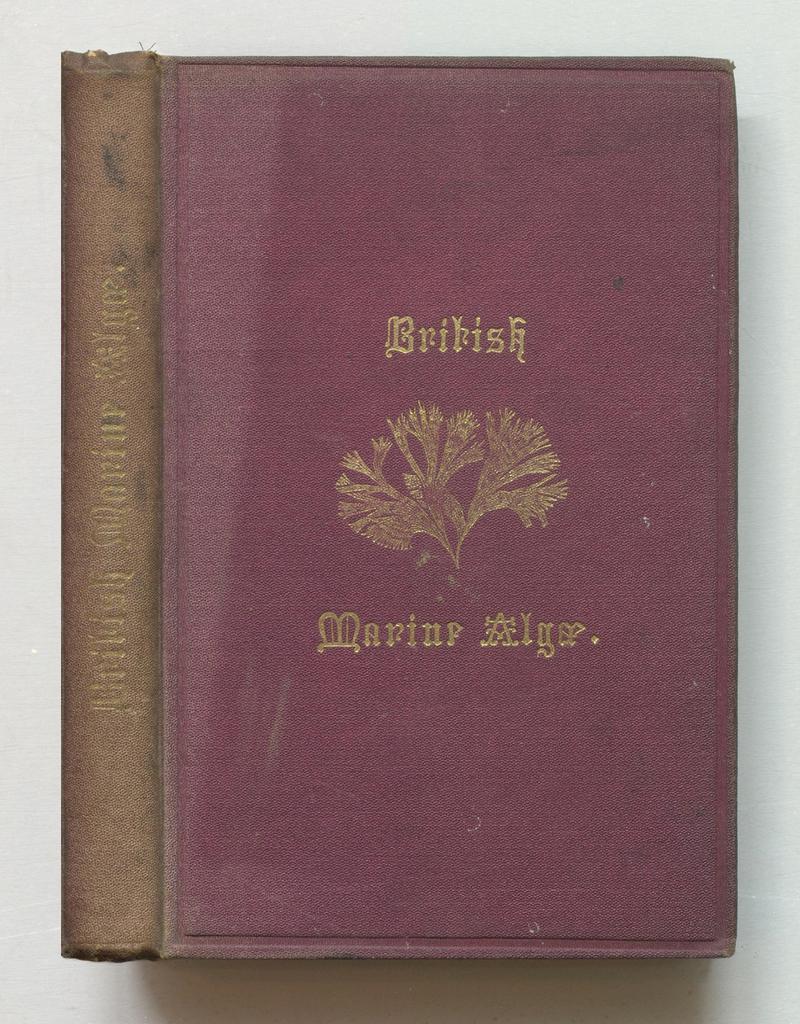What is the first word on the book?
Offer a very short reply. British. Waht is the second word on the book?
Your answer should be very brief. Marine. 